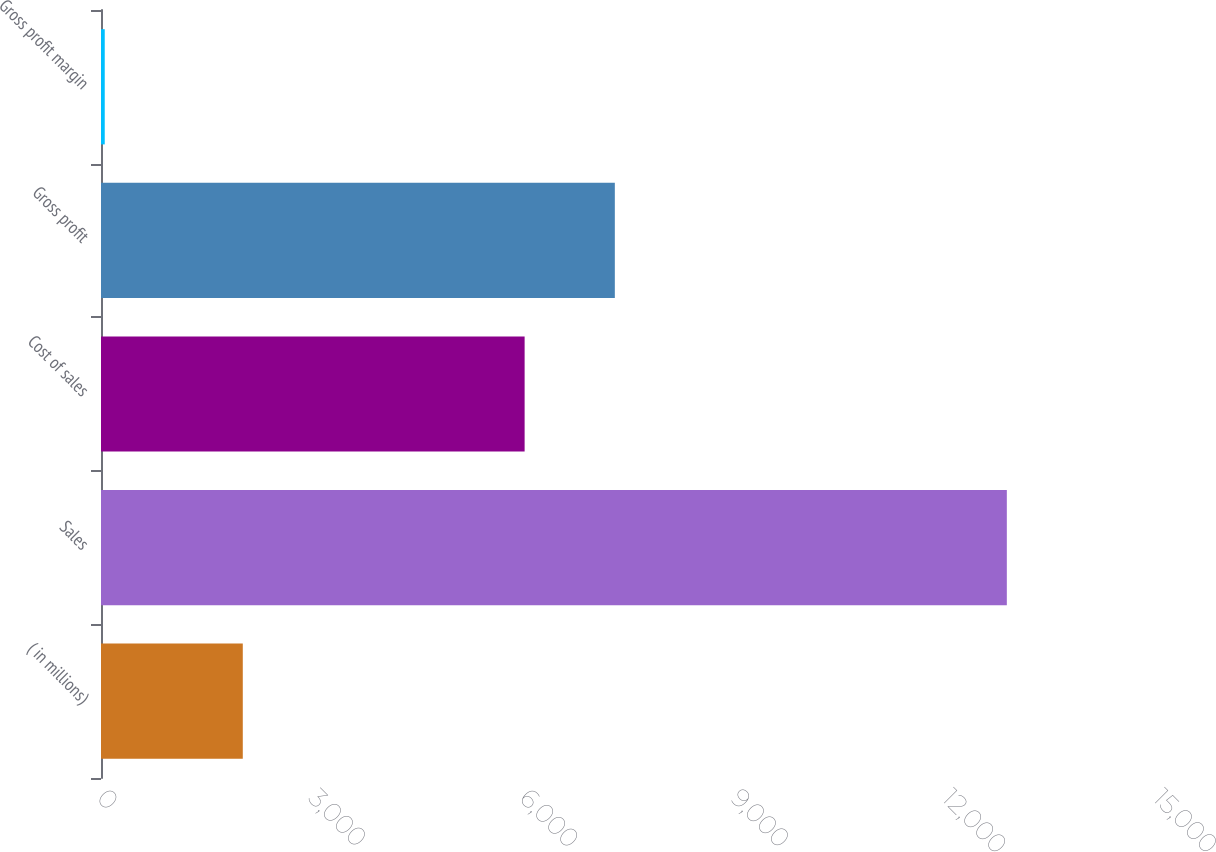<chart> <loc_0><loc_0><loc_500><loc_500><bar_chart><fcel>( in millions)<fcel>Sales<fcel>Cost of sales<fcel>Gross profit<fcel>Gross profit margin<nl><fcel>2014<fcel>12866.9<fcel>6017.4<fcel>7298.77<fcel>53.2<nl></chart> 